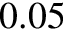Convert formula to latex. <formula><loc_0><loc_0><loc_500><loc_500>0 . 0 5</formula> 